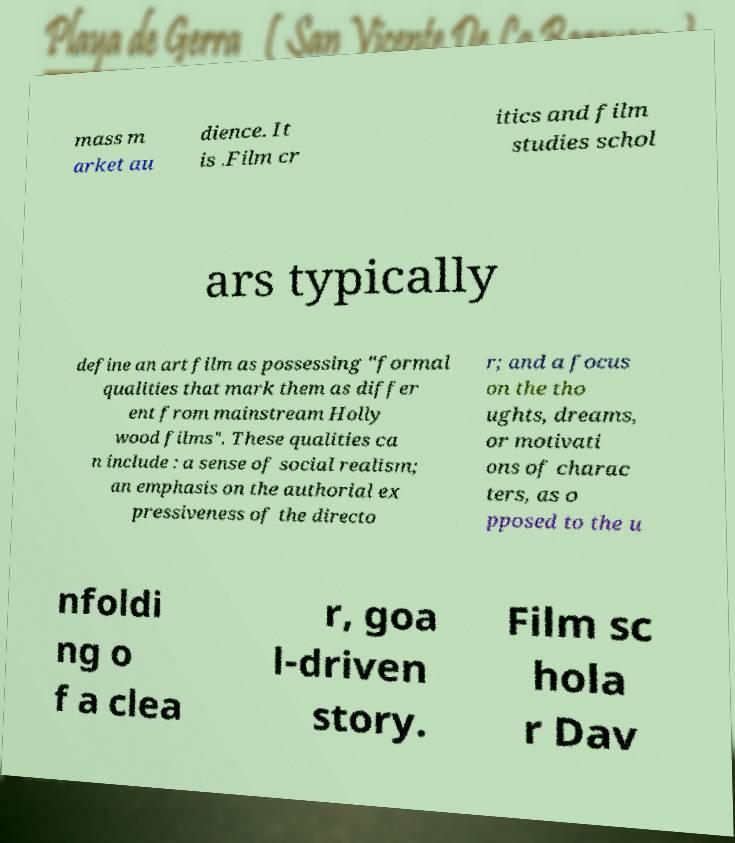There's text embedded in this image that I need extracted. Can you transcribe it verbatim? mass m arket au dience. It is .Film cr itics and film studies schol ars typically define an art film as possessing "formal qualities that mark them as differ ent from mainstream Holly wood films". These qualities ca n include : a sense of social realism; an emphasis on the authorial ex pressiveness of the directo r; and a focus on the tho ughts, dreams, or motivati ons of charac ters, as o pposed to the u nfoldi ng o f a clea r, goa l-driven story. Film sc hola r Dav 